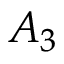<formula> <loc_0><loc_0><loc_500><loc_500>A _ { 3 }</formula> 